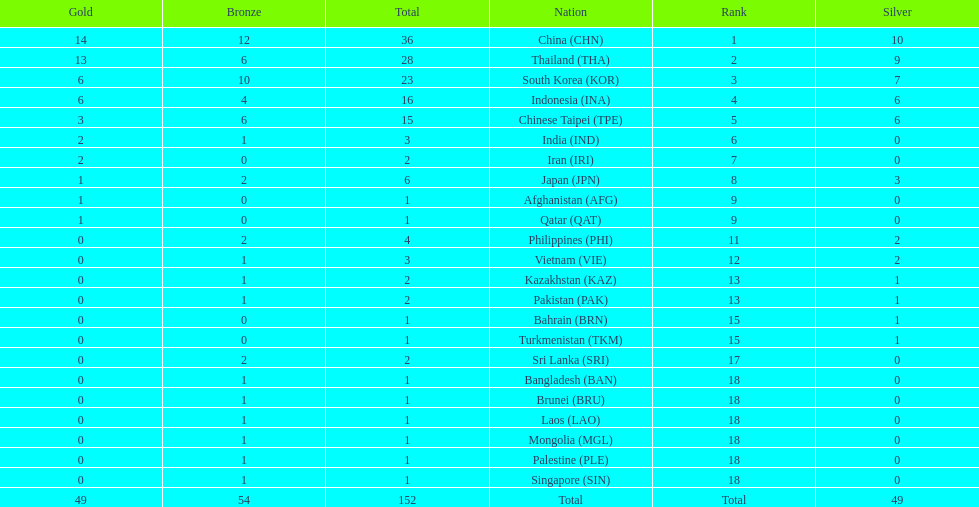Which countries won the same number of gold medals as japan? Afghanistan (AFG), Qatar (QAT). 